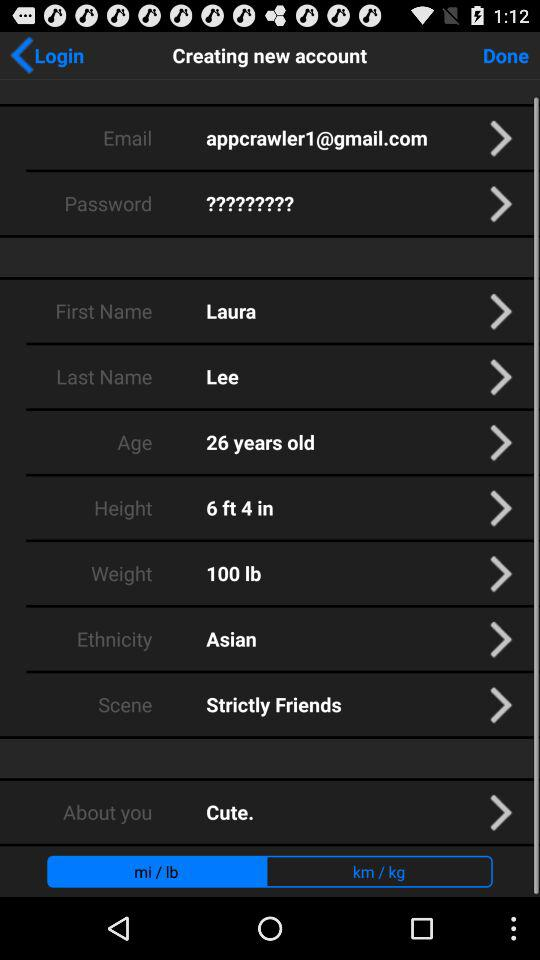What is the ethnicity? The ethnicity is "Asian". 